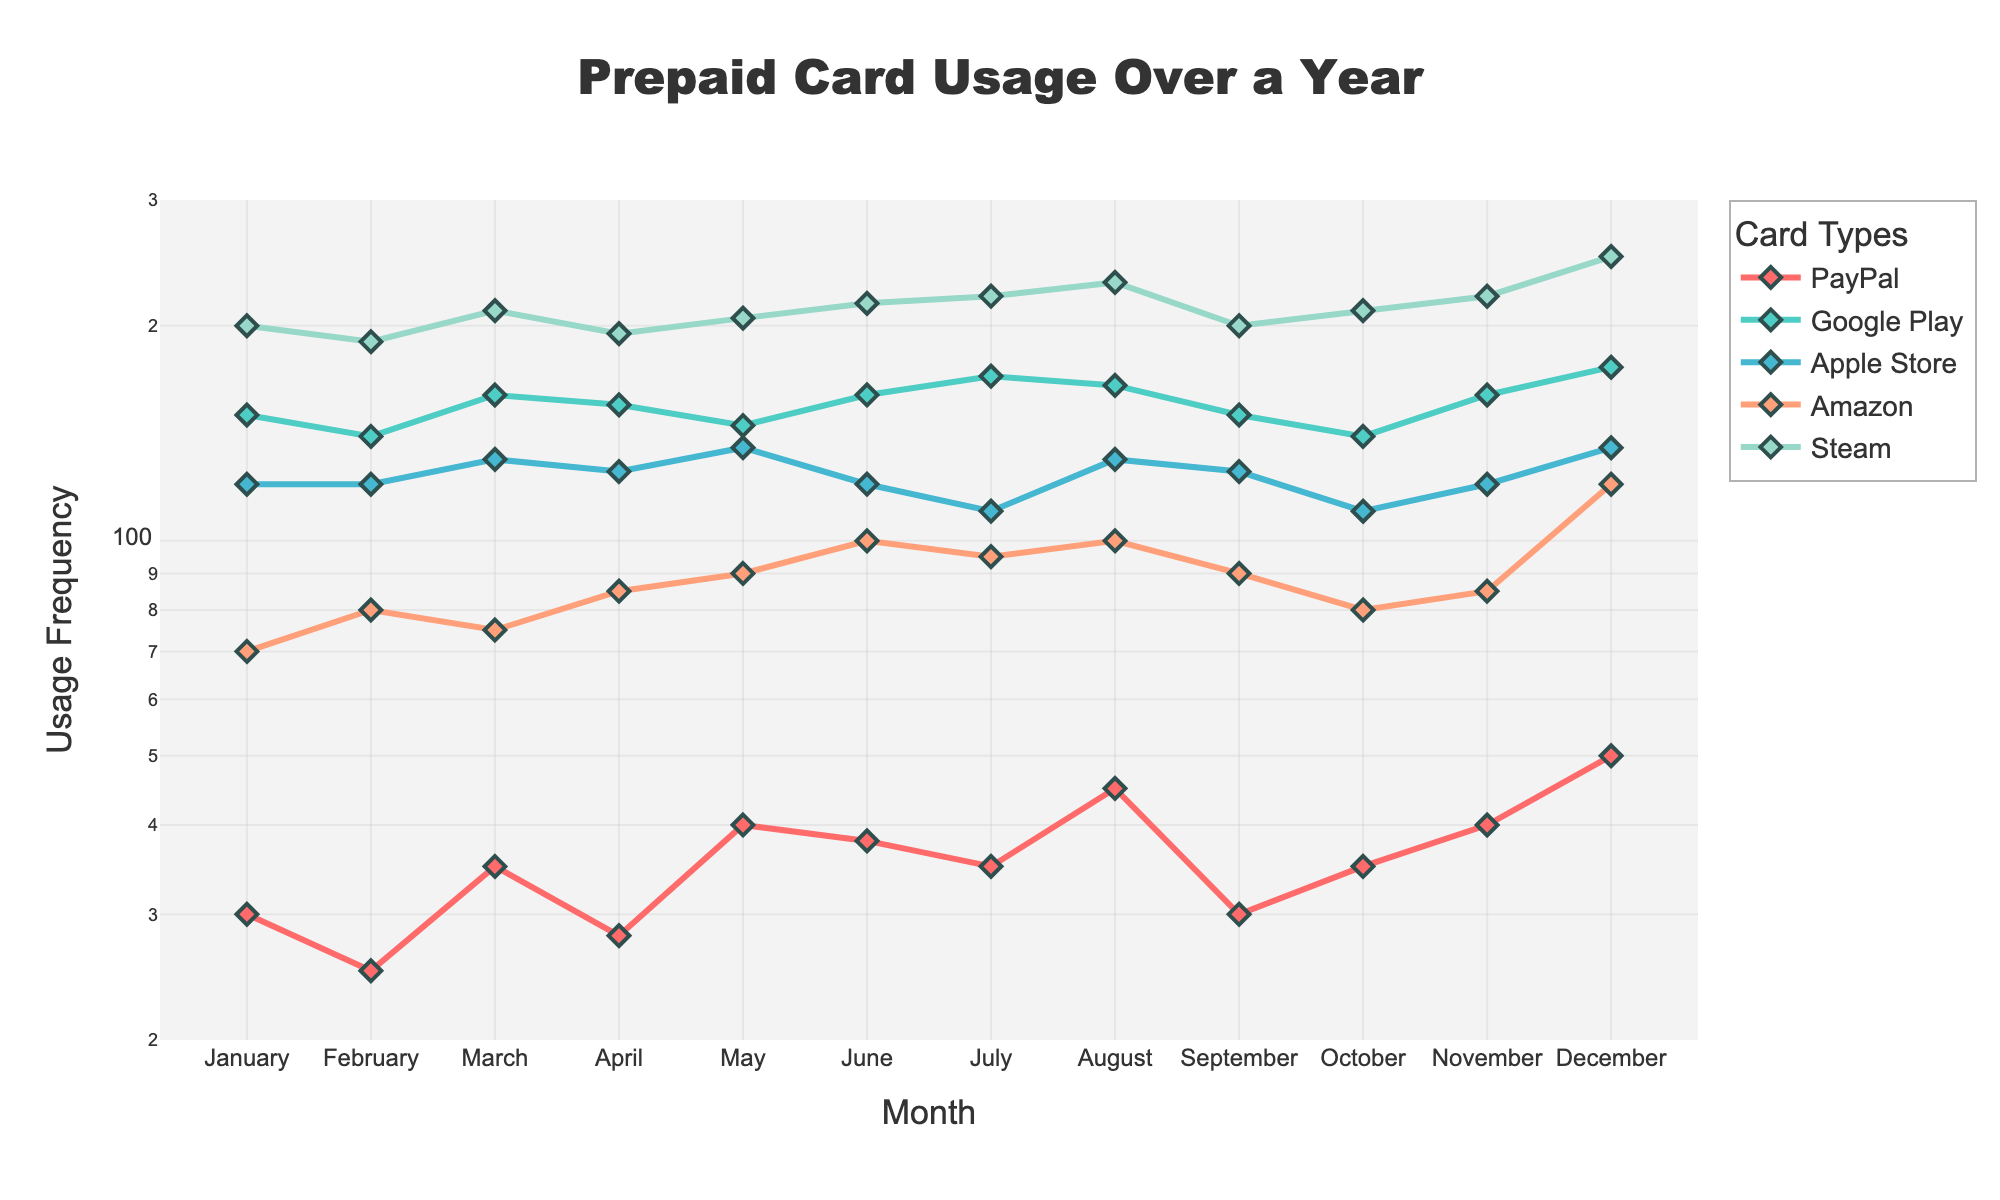What is the title of the figure? The title is displayed at the top of the figure. It reads "Prepaid Card Usage Over a Year"
Answer: Prepaid Card Usage Over a Year Which card type has the highest usage frequency in December? By looking at the December data points and identifying the highest value, we see that Steam has the highest frequency
Answer: Steam How does the usage frequency of Google Play cards change from June to July? Comparing the June and July values for Google Play, it increases from 160 to 170
Answer: It increases Which card shows the least variation in its usage frequency throughout the year? Assessing the variation requires looking at the spread of values for each card. PayPal shows relatively small deviation from month to month compared to others
Answer: PayPal What is the approximate usage frequency of Amazon cards in March? Locate the Amazon data point for March month, which approximates to 75
Answer: 75 In which month does Apple Store usage exceed PayPal usage by the largest amount, and by how much? Comparing the difference between Apple Store and PayPal for each month, the largest difference is in December: 135 (Apple Store) - 50 (PayPal) = 85
Answer: December, 85 Is there a month when Steam card usage is less than 200? If so, which one? By examining Steam's data points, it's less than 200 in January, February, April, and September
Answer: January, February, April, September What is the highest usage frequency recorded for Google Play cards, and in which month did it occur? Identifying the peak value for Google Play, it is 175 in December
Answer: 175, December How many card types have their highest frequency usage in December? Analyzing each card type, we see that PayPal, Google Play, Apple Store, Amazon, and Steam all peak in December
Answer: Five card types Which card type has the most fluctuation in usage frequency, and how can you identify it? Assessing the range or variance of each card's data, Steam clearly has the highest fluctuation in usage values
Answer: Steam 